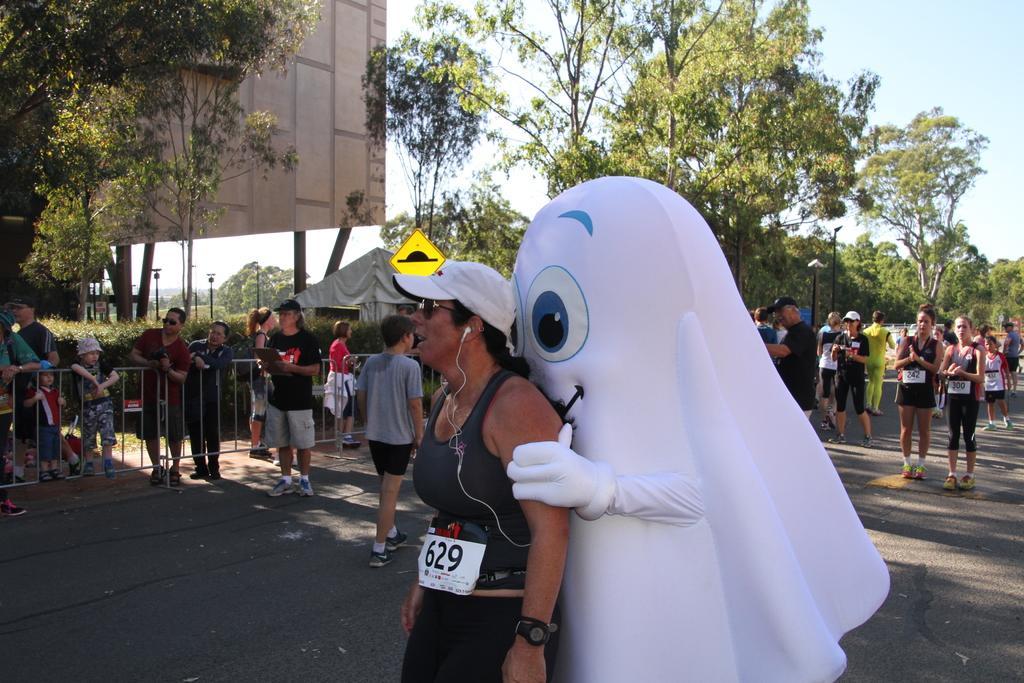Please provide a concise description of this image. This is an outside view. Here I can see a person standing on the road facing towards the left side. At the back of this person there is a toy holding this person. In the background many people are standing on the road and looking at the left side. In the background there are many trees and there is a board and also I can see few poles. On the left side there is a railing, behind few children and people are standing. At the top of the image I can see the sky. 